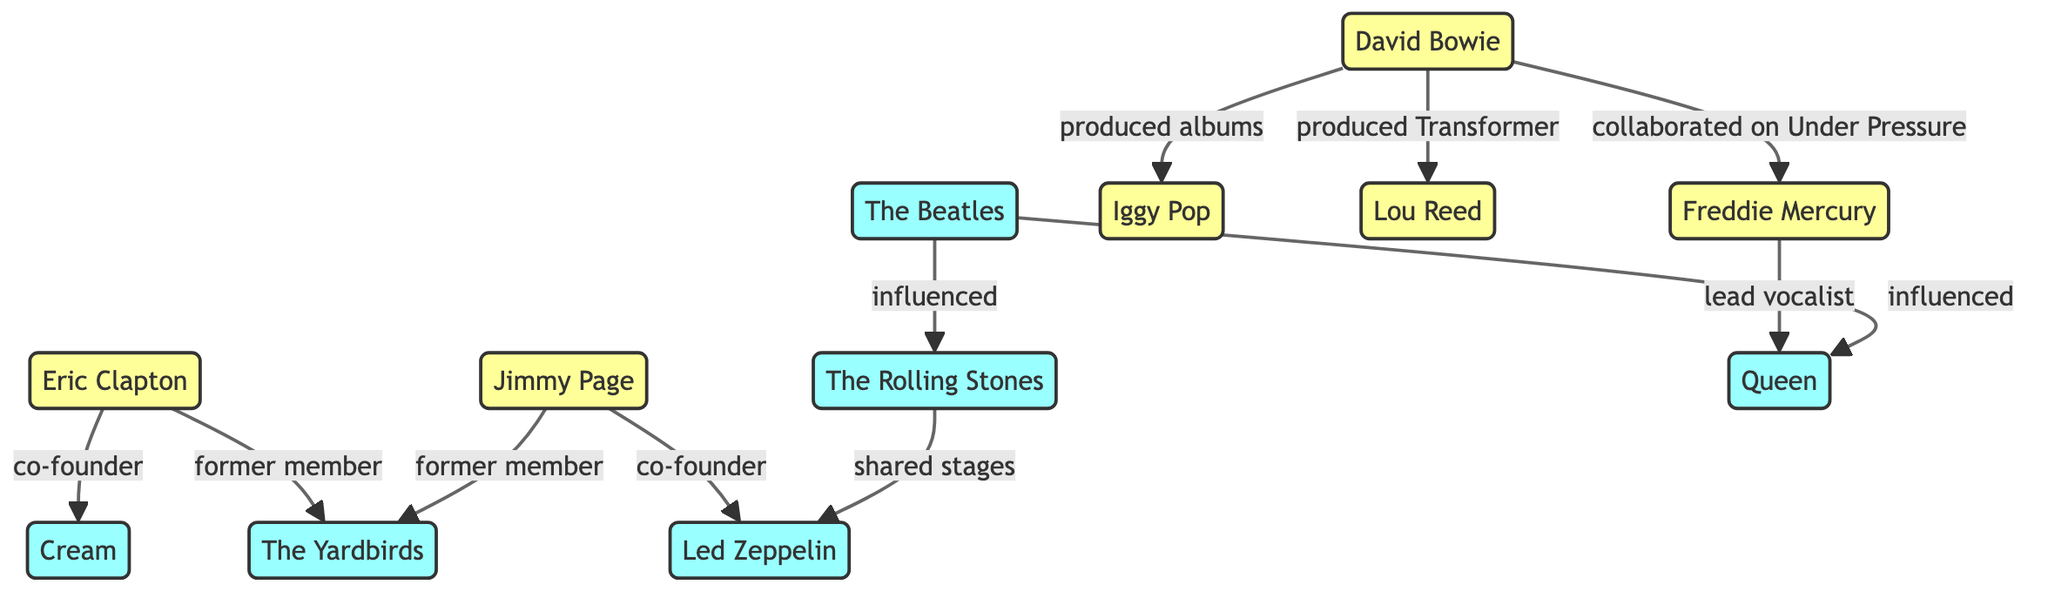What is the relationship between Eric Clapton and Cream? The diagram shows that Eric Clapton is labeled as a 'co-founder' of Cream, indicating that he played a significant role in forming this band.
Answer: co-founder How many solo artists are represented in the diagram? By counting the nodes classified as 'solo', we find there are five: Eric Clapton, Jimmy Page, David Bowie, Iggy Pop, and Lou Reed.
Answer: 5 Which band influenced the Rolling Stones? The diagram indicates a direct connection from The Beatles to the Rolling Stones, classifying The Beatles as an influence on them.
Answer: The Beatles Who produced albums for Iggy Pop? The diagram specifies that David Bowie produced albums for Iggy Pop, establishing a direct connection between the two.
Answer: David Bowie What role did Freddie Mercury have in Queen? The diagram explicitly states that Freddie Mercury is the 'lead vocalist' of Queen, defining his primary contribution to this band.
Answer: lead vocalist Which band shared stages with Led Zeppelin? The diagram connects the Rolling Stones to Led Zeppelin, indicating that they shared stages, which denotes collaborative presence.
Answer: Rolling Stones What is the total number of bands displayed in the diagram? In the diagram, we can identify five nodes classified as 'band': The Beatles, The Rolling Stones, Led Zeppelin, Cream, and Queen, thus totaling to five bands.
Answer: 5 Which two artists collaborated on the song Under Pressure? The diagram illustrates a connection between David Bowie and Freddie Mercury regarding the collaboration on Under Pressure, which signifies their partnership for that piece.
Answer: David Bowie and Freddie Mercury Which former members belong to The Yardbirds? The diagram highlights Eric Clapton and Jimmy Page as relations connected to The Yardbirds, indicating that both were former members of this band.
Answer: Eric Clapton and Jimmy Page 